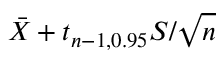<formula> <loc_0><loc_0><loc_500><loc_500>{ \bar { X } } + t _ { n - 1 , 0 . 9 5 } S / { \sqrt { n } }</formula> 